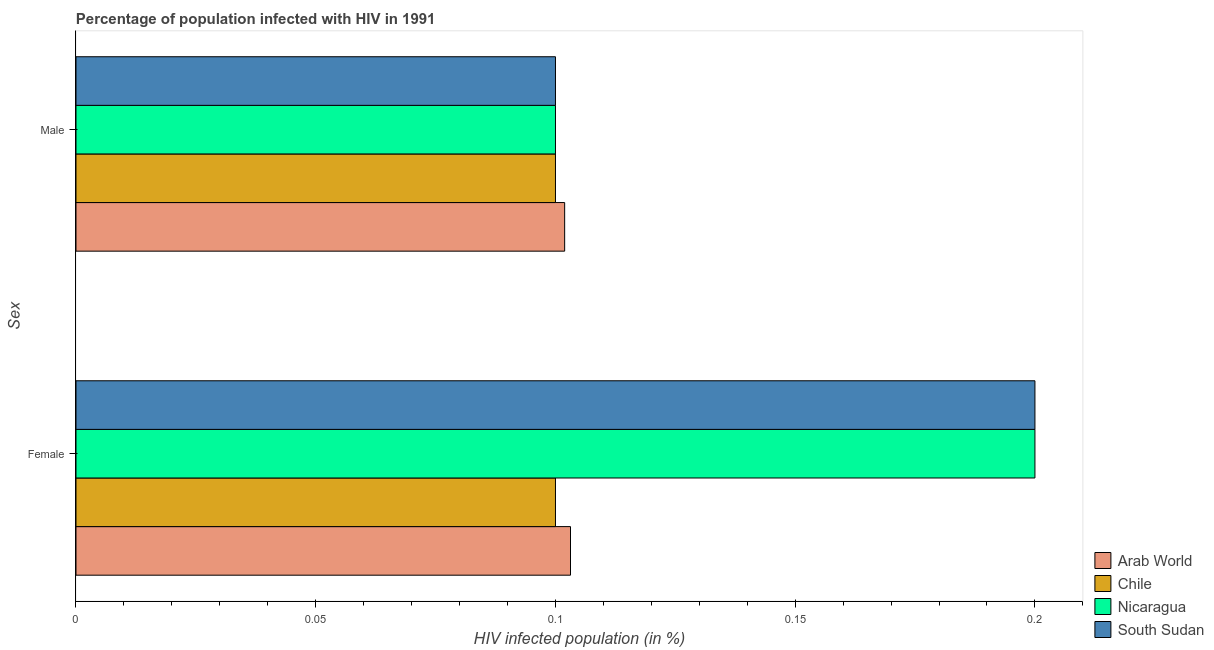How many different coloured bars are there?
Offer a terse response. 4. Are the number of bars on each tick of the Y-axis equal?
Ensure brevity in your answer.  Yes. How many bars are there on the 1st tick from the bottom?
Your answer should be compact. 4. What is the label of the 2nd group of bars from the top?
Your answer should be compact. Female. What is the percentage of females who are infected with hiv in South Sudan?
Offer a terse response. 0.2. Across all countries, what is the maximum percentage of males who are infected with hiv?
Provide a short and direct response. 0.1. In which country was the percentage of females who are infected with hiv maximum?
Your response must be concise. Nicaragua. What is the total percentage of females who are infected with hiv in the graph?
Your answer should be very brief. 0.6. What is the difference between the percentage of females who are infected with hiv in South Sudan and the percentage of males who are infected with hiv in Arab World?
Your response must be concise. 0.1. What is the average percentage of females who are infected with hiv per country?
Offer a very short reply. 0.15. What is the difference between the percentage of males who are infected with hiv and percentage of females who are infected with hiv in Arab World?
Your response must be concise. -0. What is the ratio of the percentage of females who are infected with hiv in Chile to that in Nicaragua?
Make the answer very short. 0.5. What does the 2nd bar from the top in Male represents?
Offer a very short reply. Nicaragua. How many bars are there?
Provide a succinct answer. 8. Are all the bars in the graph horizontal?
Your response must be concise. Yes. What is the difference between two consecutive major ticks on the X-axis?
Offer a terse response. 0.05. Does the graph contain grids?
Make the answer very short. No. Where does the legend appear in the graph?
Provide a succinct answer. Bottom right. How are the legend labels stacked?
Provide a short and direct response. Vertical. What is the title of the graph?
Give a very brief answer. Percentage of population infected with HIV in 1991. What is the label or title of the X-axis?
Give a very brief answer. HIV infected population (in %). What is the label or title of the Y-axis?
Offer a very short reply. Sex. What is the HIV infected population (in %) in Arab World in Female?
Your answer should be very brief. 0.1. What is the HIV infected population (in %) in Chile in Female?
Make the answer very short. 0.1. What is the HIV infected population (in %) of Nicaragua in Female?
Provide a succinct answer. 0.2. What is the HIV infected population (in %) of Arab World in Male?
Keep it short and to the point. 0.1. What is the HIV infected population (in %) in Chile in Male?
Your response must be concise. 0.1. What is the HIV infected population (in %) of South Sudan in Male?
Your response must be concise. 0.1. Across all Sex, what is the maximum HIV infected population (in %) of Arab World?
Give a very brief answer. 0.1. Across all Sex, what is the maximum HIV infected population (in %) in Nicaragua?
Your answer should be compact. 0.2. Across all Sex, what is the maximum HIV infected population (in %) of South Sudan?
Provide a succinct answer. 0.2. Across all Sex, what is the minimum HIV infected population (in %) in Arab World?
Provide a short and direct response. 0.1. What is the total HIV infected population (in %) of Arab World in the graph?
Make the answer very short. 0.21. What is the difference between the HIV infected population (in %) in Arab World in Female and that in Male?
Your response must be concise. 0. What is the difference between the HIV infected population (in %) of Chile in Female and that in Male?
Provide a succinct answer. 0. What is the difference between the HIV infected population (in %) of Arab World in Female and the HIV infected population (in %) of Chile in Male?
Provide a succinct answer. 0. What is the difference between the HIV infected population (in %) in Arab World in Female and the HIV infected population (in %) in Nicaragua in Male?
Offer a terse response. 0. What is the difference between the HIV infected population (in %) of Arab World in Female and the HIV infected population (in %) of South Sudan in Male?
Offer a very short reply. 0. What is the difference between the HIV infected population (in %) of Chile in Female and the HIV infected population (in %) of Nicaragua in Male?
Provide a short and direct response. 0. What is the difference between the HIV infected population (in %) of Nicaragua in Female and the HIV infected population (in %) of South Sudan in Male?
Offer a terse response. 0.1. What is the average HIV infected population (in %) of Arab World per Sex?
Your answer should be very brief. 0.1. What is the average HIV infected population (in %) in Chile per Sex?
Ensure brevity in your answer.  0.1. What is the average HIV infected population (in %) of Nicaragua per Sex?
Offer a very short reply. 0.15. What is the average HIV infected population (in %) of South Sudan per Sex?
Give a very brief answer. 0.15. What is the difference between the HIV infected population (in %) of Arab World and HIV infected population (in %) of Chile in Female?
Your response must be concise. 0. What is the difference between the HIV infected population (in %) of Arab World and HIV infected population (in %) of Nicaragua in Female?
Offer a very short reply. -0.1. What is the difference between the HIV infected population (in %) of Arab World and HIV infected population (in %) of South Sudan in Female?
Provide a succinct answer. -0.1. What is the difference between the HIV infected population (in %) in Chile and HIV infected population (in %) in South Sudan in Female?
Offer a very short reply. -0.1. What is the difference between the HIV infected population (in %) of Nicaragua and HIV infected population (in %) of South Sudan in Female?
Your response must be concise. 0. What is the difference between the HIV infected population (in %) in Arab World and HIV infected population (in %) in Chile in Male?
Your answer should be compact. 0. What is the difference between the HIV infected population (in %) in Arab World and HIV infected population (in %) in Nicaragua in Male?
Make the answer very short. 0. What is the difference between the HIV infected population (in %) of Arab World and HIV infected population (in %) of South Sudan in Male?
Ensure brevity in your answer.  0. What is the difference between the HIV infected population (in %) in Nicaragua and HIV infected population (in %) in South Sudan in Male?
Offer a very short reply. 0. What is the ratio of the HIV infected population (in %) in Chile in Female to that in Male?
Your response must be concise. 1. What is the ratio of the HIV infected population (in %) of Nicaragua in Female to that in Male?
Keep it short and to the point. 2. What is the ratio of the HIV infected population (in %) of South Sudan in Female to that in Male?
Your response must be concise. 2. What is the difference between the highest and the second highest HIV infected population (in %) of Arab World?
Ensure brevity in your answer.  0. What is the difference between the highest and the second highest HIV infected population (in %) in Nicaragua?
Provide a succinct answer. 0.1. What is the difference between the highest and the lowest HIV infected population (in %) of Arab World?
Provide a short and direct response. 0. What is the difference between the highest and the lowest HIV infected population (in %) in Chile?
Offer a terse response. 0. What is the difference between the highest and the lowest HIV infected population (in %) of Nicaragua?
Your answer should be very brief. 0.1. 